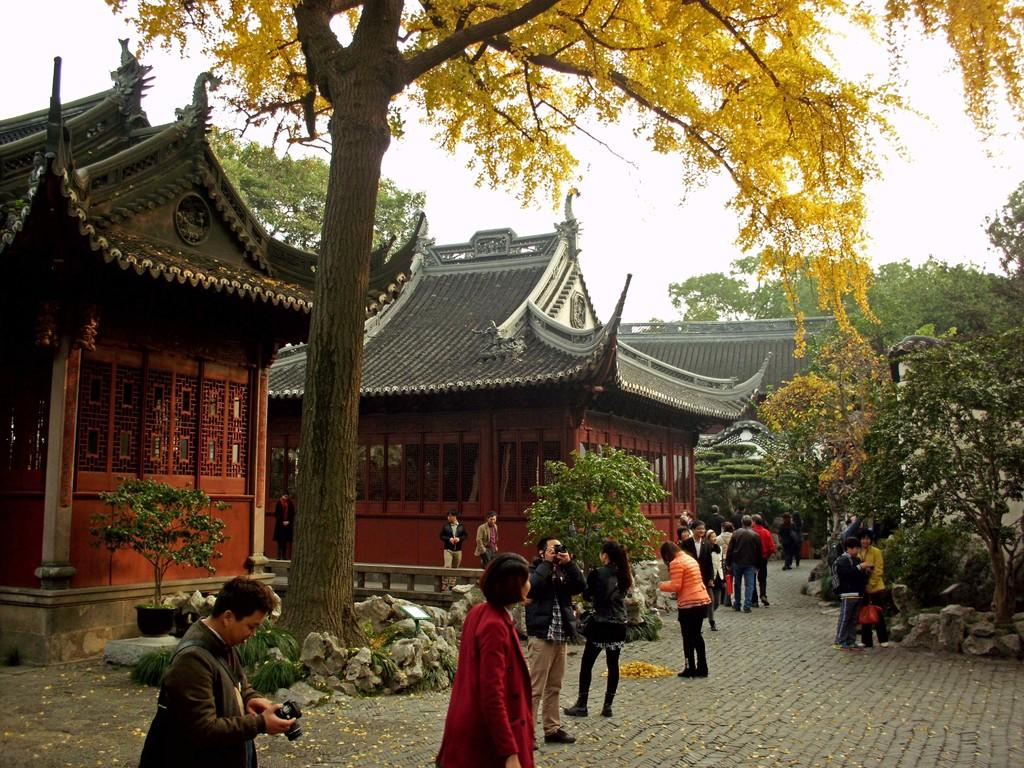What is the man on the left side of the image doing? The man on the left side of the image is standing and holding a camera. What can be observed about the houses in the image? The houses in the image are in red color. What is the prominent natural feature in the middle of the image? There is a big tree in the middle of the image. Are there any other people present in the image besides the man with the camera? Yes, there are other people standing in the image. Can you see any receipts or documents related to the purchase of the tree in the image? There is no mention of receipts or documents related to the purchase of the tree in the image. 